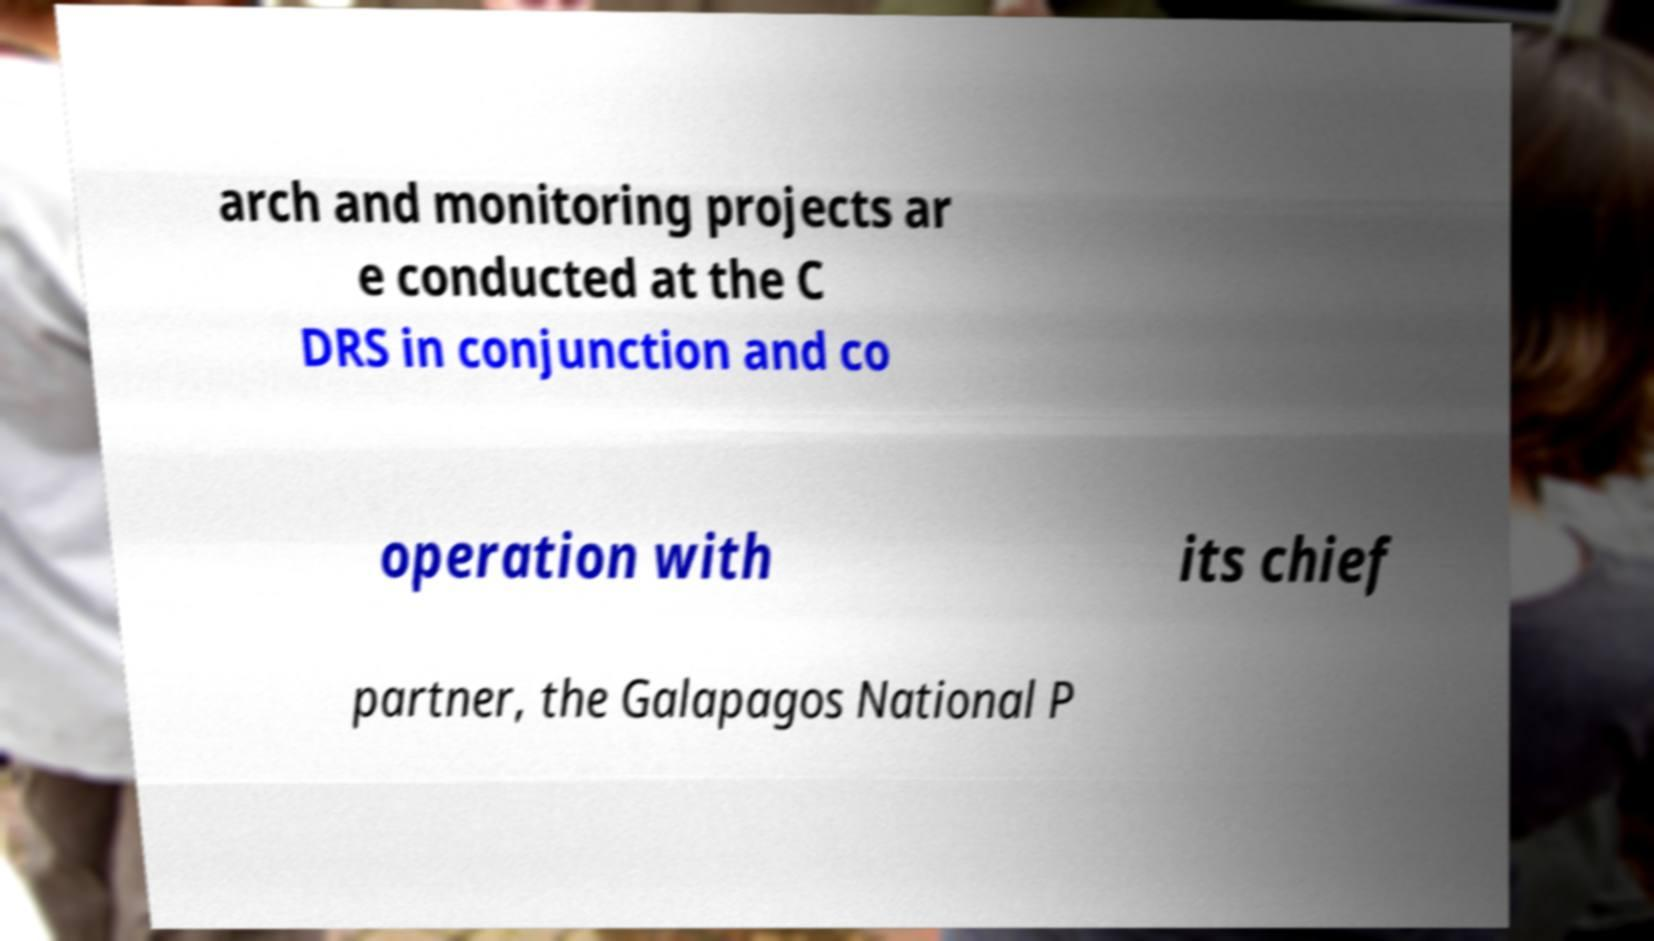Can you read and provide the text displayed in the image?This photo seems to have some interesting text. Can you extract and type it out for me? arch and monitoring projects ar e conducted at the C DRS in conjunction and co operation with its chief partner, the Galapagos National P 